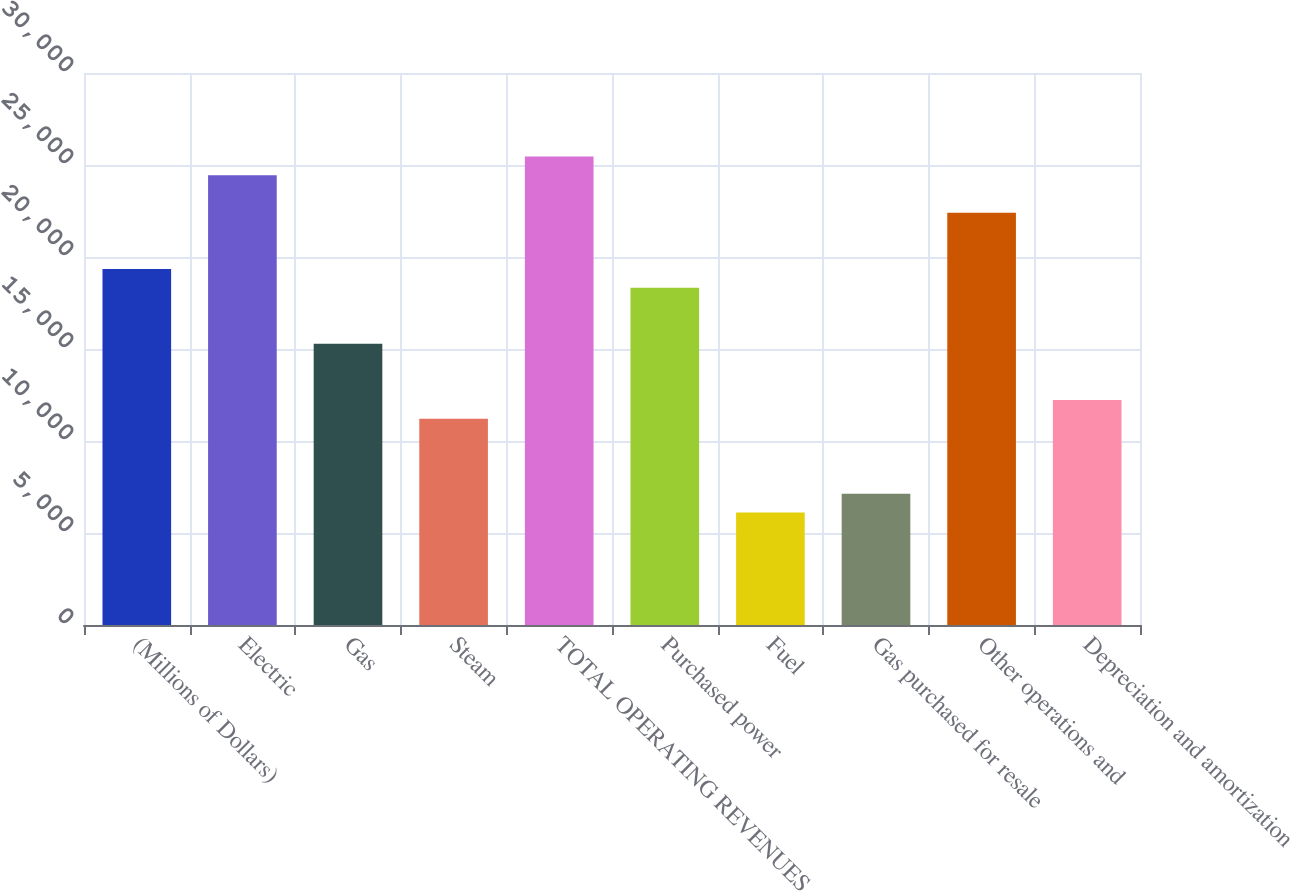<chart> <loc_0><loc_0><loc_500><loc_500><bar_chart><fcel>(Millions of Dollars)<fcel>Electric<fcel>Gas<fcel>Steam<fcel>TOTAL OPERATING REVENUES<fcel>Purchased power<fcel>Fuel<fcel>Gas purchased for resale<fcel>Other operations and<fcel>Depreciation and amortization<nl><fcel>19353.5<fcel>24446<fcel>15279.5<fcel>11205.5<fcel>25464.5<fcel>18335<fcel>6113<fcel>7131.5<fcel>22409<fcel>12224<nl></chart> 